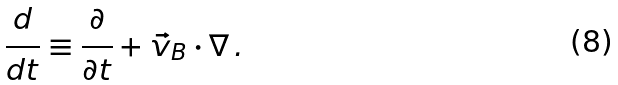Convert formula to latex. <formula><loc_0><loc_0><loc_500><loc_500>\frac { d } { d t } \equiv \frac { \partial } { \partial t } + \vec { v } _ { B } \cdot \nabla \, .</formula> 